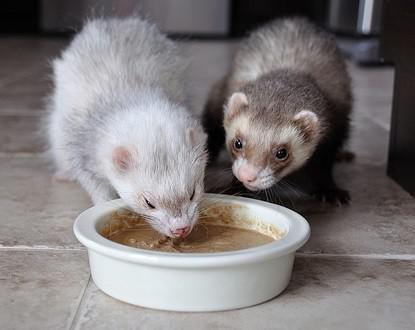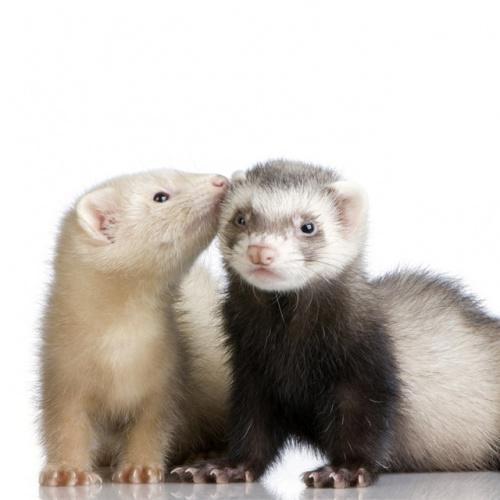The first image is the image on the left, the second image is the image on the right. For the images displayed, is the sentence "At least one of the images has exactly one ferret." factually correct? Answer yes or no. No. 